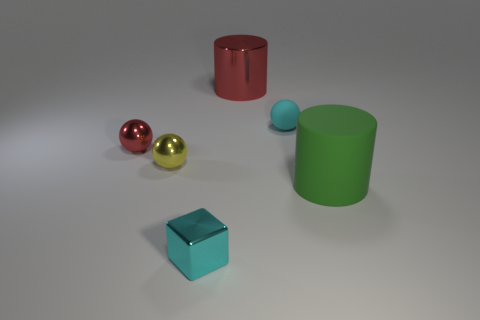Are the big cylinder behind the cyan sphere and the small red ball made of the same material?
Ensure brevity in your answer.  Yes. There is a large matte thing; is it the same color as the cylinder that is behind the large green rubber cylinder?
Offer a very short reply. No. Are there any big red metallic things in front of the small yellow metal thing?
Your response must be concise. No. There is a red object on the left side of the red shiny cylinder; is it the same size as the cyan object that is behind the big green matte thing?
Your response must be concise. Yes. Is there another matte sphere of the same size as the cyan rubber ball?
Your answer should be compact. No. There is a small shiny object that is in front of the big green rubber cylinder; is it the same shape as the big green object?
Offer a terse response. No. There is a big cylinder in front of the red metal sphere; what is its material?
Make the answer very short. Rubber. What shape is the big thing in front of the large cylinder that is on the left side of the tiny cyan sphere?
Your answer should be very brief. Cylinder. There is a tiny cyan matte thing; does it have the same shape as the big thing that is in front of the red shiny cylinder?
Your answer should be compact. No. There is a big cylinder to the left of the green cylinder; how many yellow things are to the right of it?
Your response must be concise. 0. 